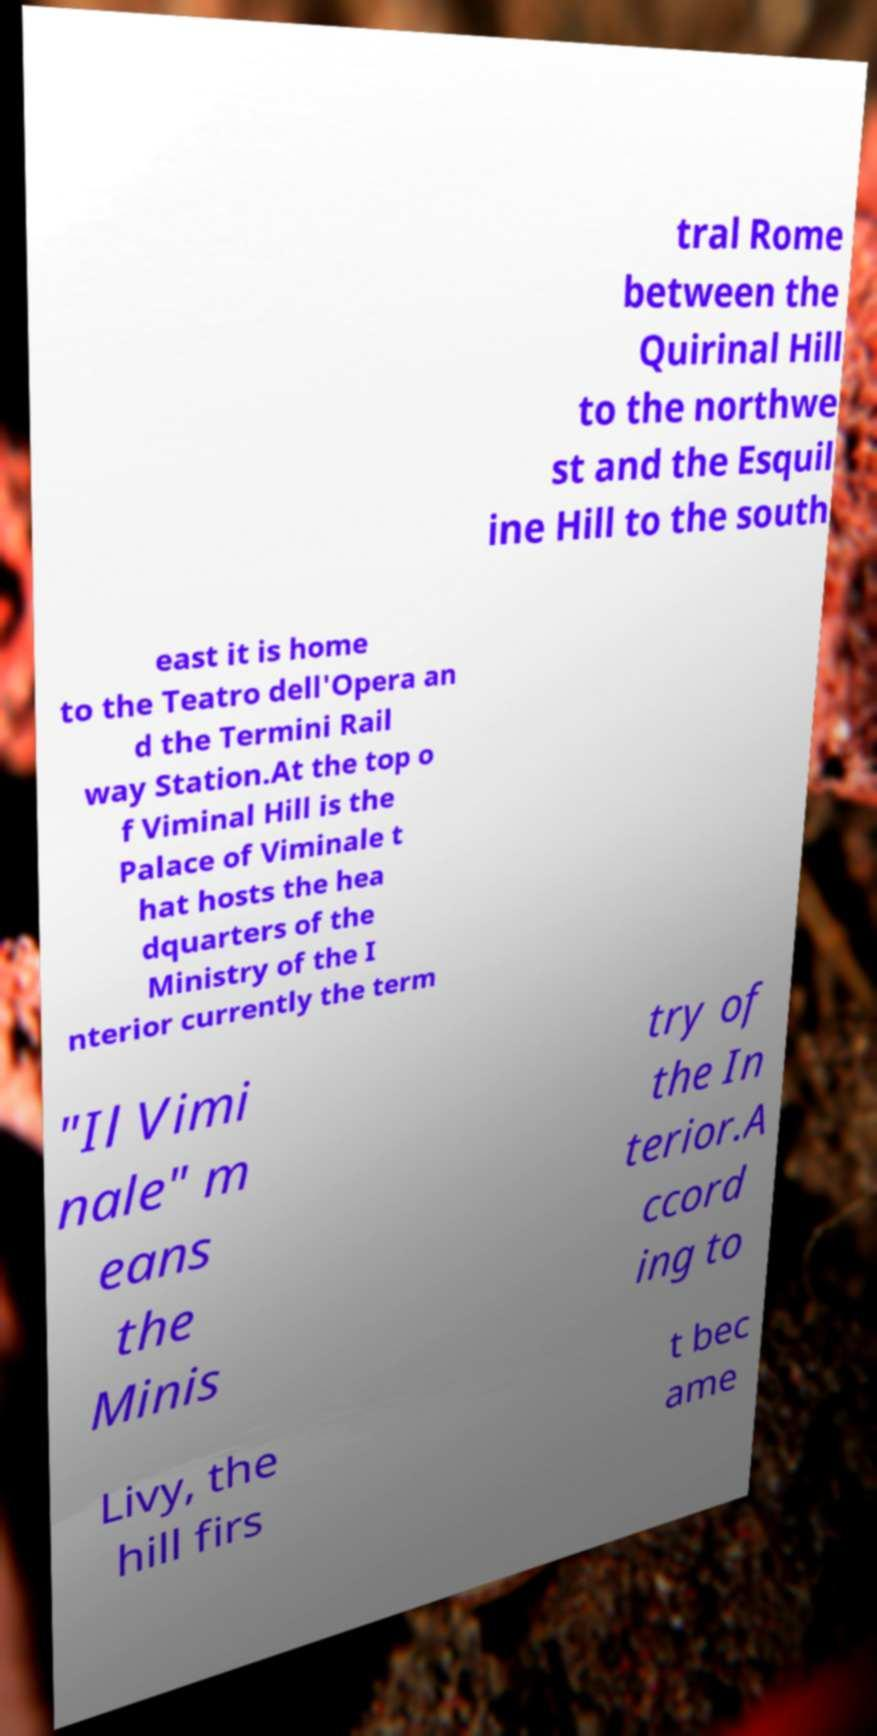Please read and relay the text visible in this image. What does it say? tral Rome between the Quirinal Hill to the northwe st and the Esquil ine Hill to the south east it is home to the Teatro dell'Opera an d the Termini Rail way Station.At the top o f Viminal Hill is the Palace of Viminale t hat hosts the hea dquarters of the Ministry of the I nterior currently the term "Il Vimi nale" m eans the Minis try of the In terior.A ccord ing to Livy, the hill firs t bec ame 